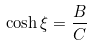<formula> <loc_0><loc_0><loc_500><loc_500>\cosh \xi = \frac { B } { C }</formula> 